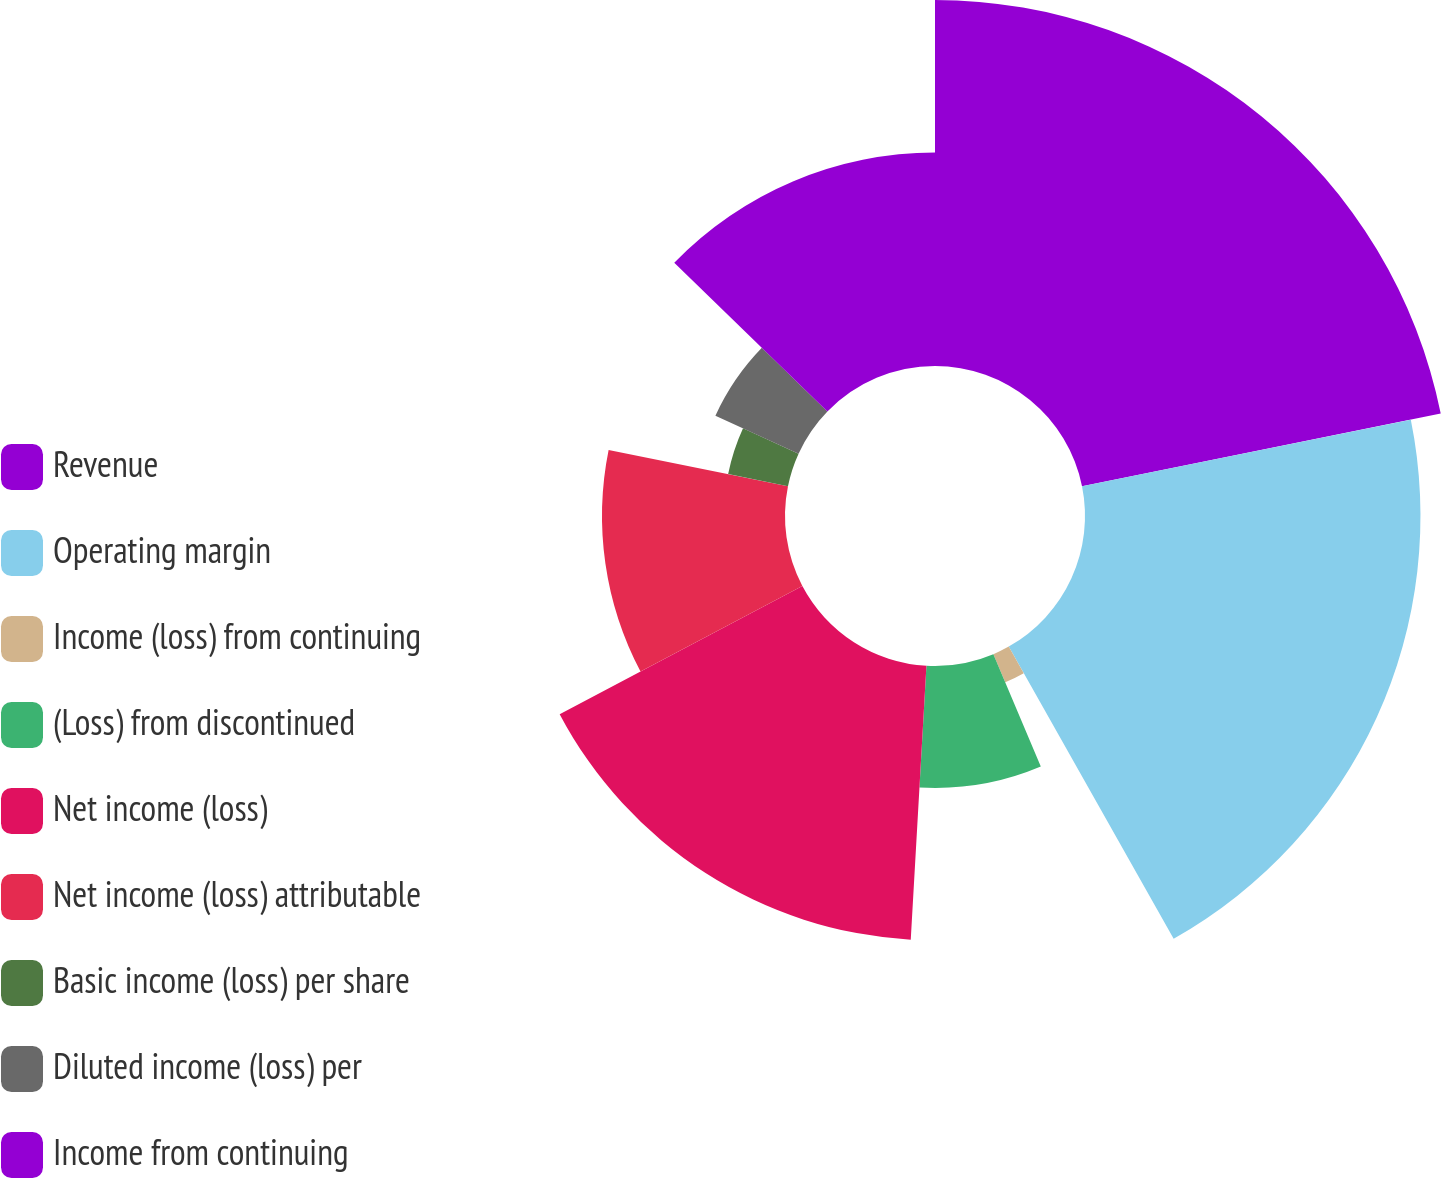Convert chart to OTSL. <chart><loc_0><loc_0><loc_500><loc_500><pie_chart><fcel>Revenue<fcel>Operating margin<fcel>Income (loss) from continuing<fcel>(Loss) from discontinued<fcel>Net income (loss)<fcel>Net income (loss) attributable<fcel>Basic income (loss) per share<fcel>Diluted income (loss) per<fcel>Income from continuing<nl><fcel>21.82%<fcel>20.0%<fcel>1.82%<fcel>7.27%<fcel>16.36%<fcel>10.91%<fcel>3.64%<fcel>5.45%<fcel>12.73%<nl></chart> 